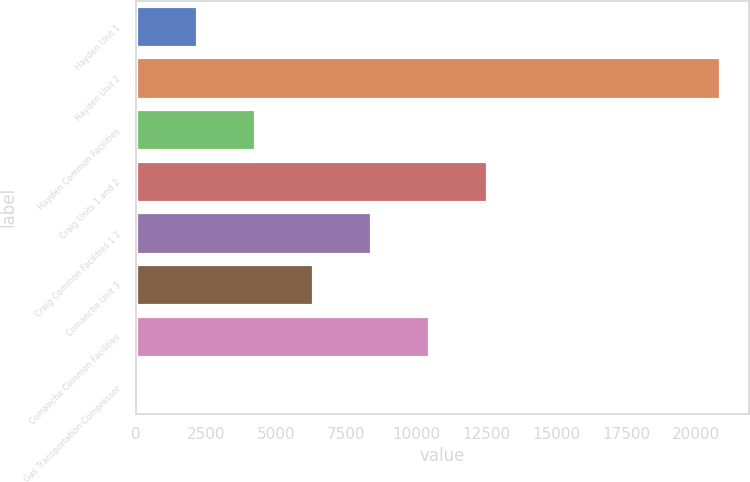Convert chart to OTSL. <chart><loc_0><loc_0><loc_500><loc_500><bar_chart><fcel>Hayden Unit 1<fcel>Hayden Unit 2<fcel>Hayden Common Facilities<fcel>Craig Units 1 and 2<fcel>Craig Common Facilities 1 2<fcel>Comanche Unit 3<fcel>Comanche Common Facilities<fcel>Gas Transportation Compressor<nl><fcel>2198.3<fcel>20840<fcel>4269.6<fcel>12554.8<fcel>8412.2<fcel>6340.9<fcel>10483.5<fcel>127<nl></chart> 